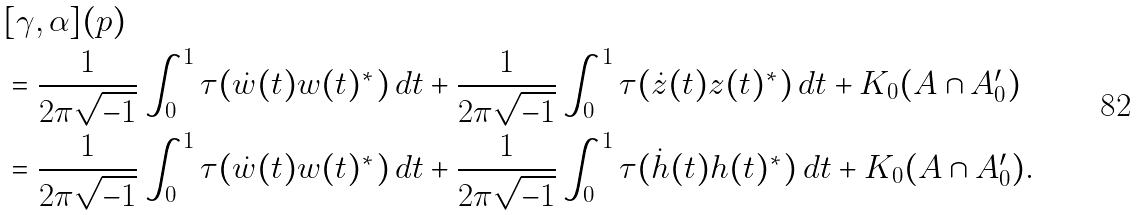<formula> <loc_0><loc_0><loc_500><loc_500>& [ \gamma , \alpha ] ( p ) \\ & = \frac { 1 } { 2 \pi \sqrt { - 1 } } \int _ { 0 } ^ { 1 } \tau ( \dot { w } ( t ) w ( t ) ^ { * } ) \, d t + \frac { 1 } { 2 \pi \sqrt { - 1 } } \int _ { 0 } ^ { 1 } \tau ( \dot { z } ( t ) z ( t ) ^ { * } ) \, d t + K _ { 0 } ( A \cap A _ { 0 } ^ { \prime } ) \\ & = \frac { 1 } { 2 \pi \sqrt { - 1 } } \int _ { 0 } ^ { 1 } \tau ( \dot { w } ( t ) w ( t ) ^ { * } ) \, d t + \frac { 1 } { 2 \pi \sqrt { - 1 } } \int _ { 0 } ^ { 1 } \tau ( \dot { h } ( t ) h ( t ) ^ { * } ) \, d t + K _ { 0 } ( A \cap A _ { 0 } ^ { \prime } ) .</formula> 